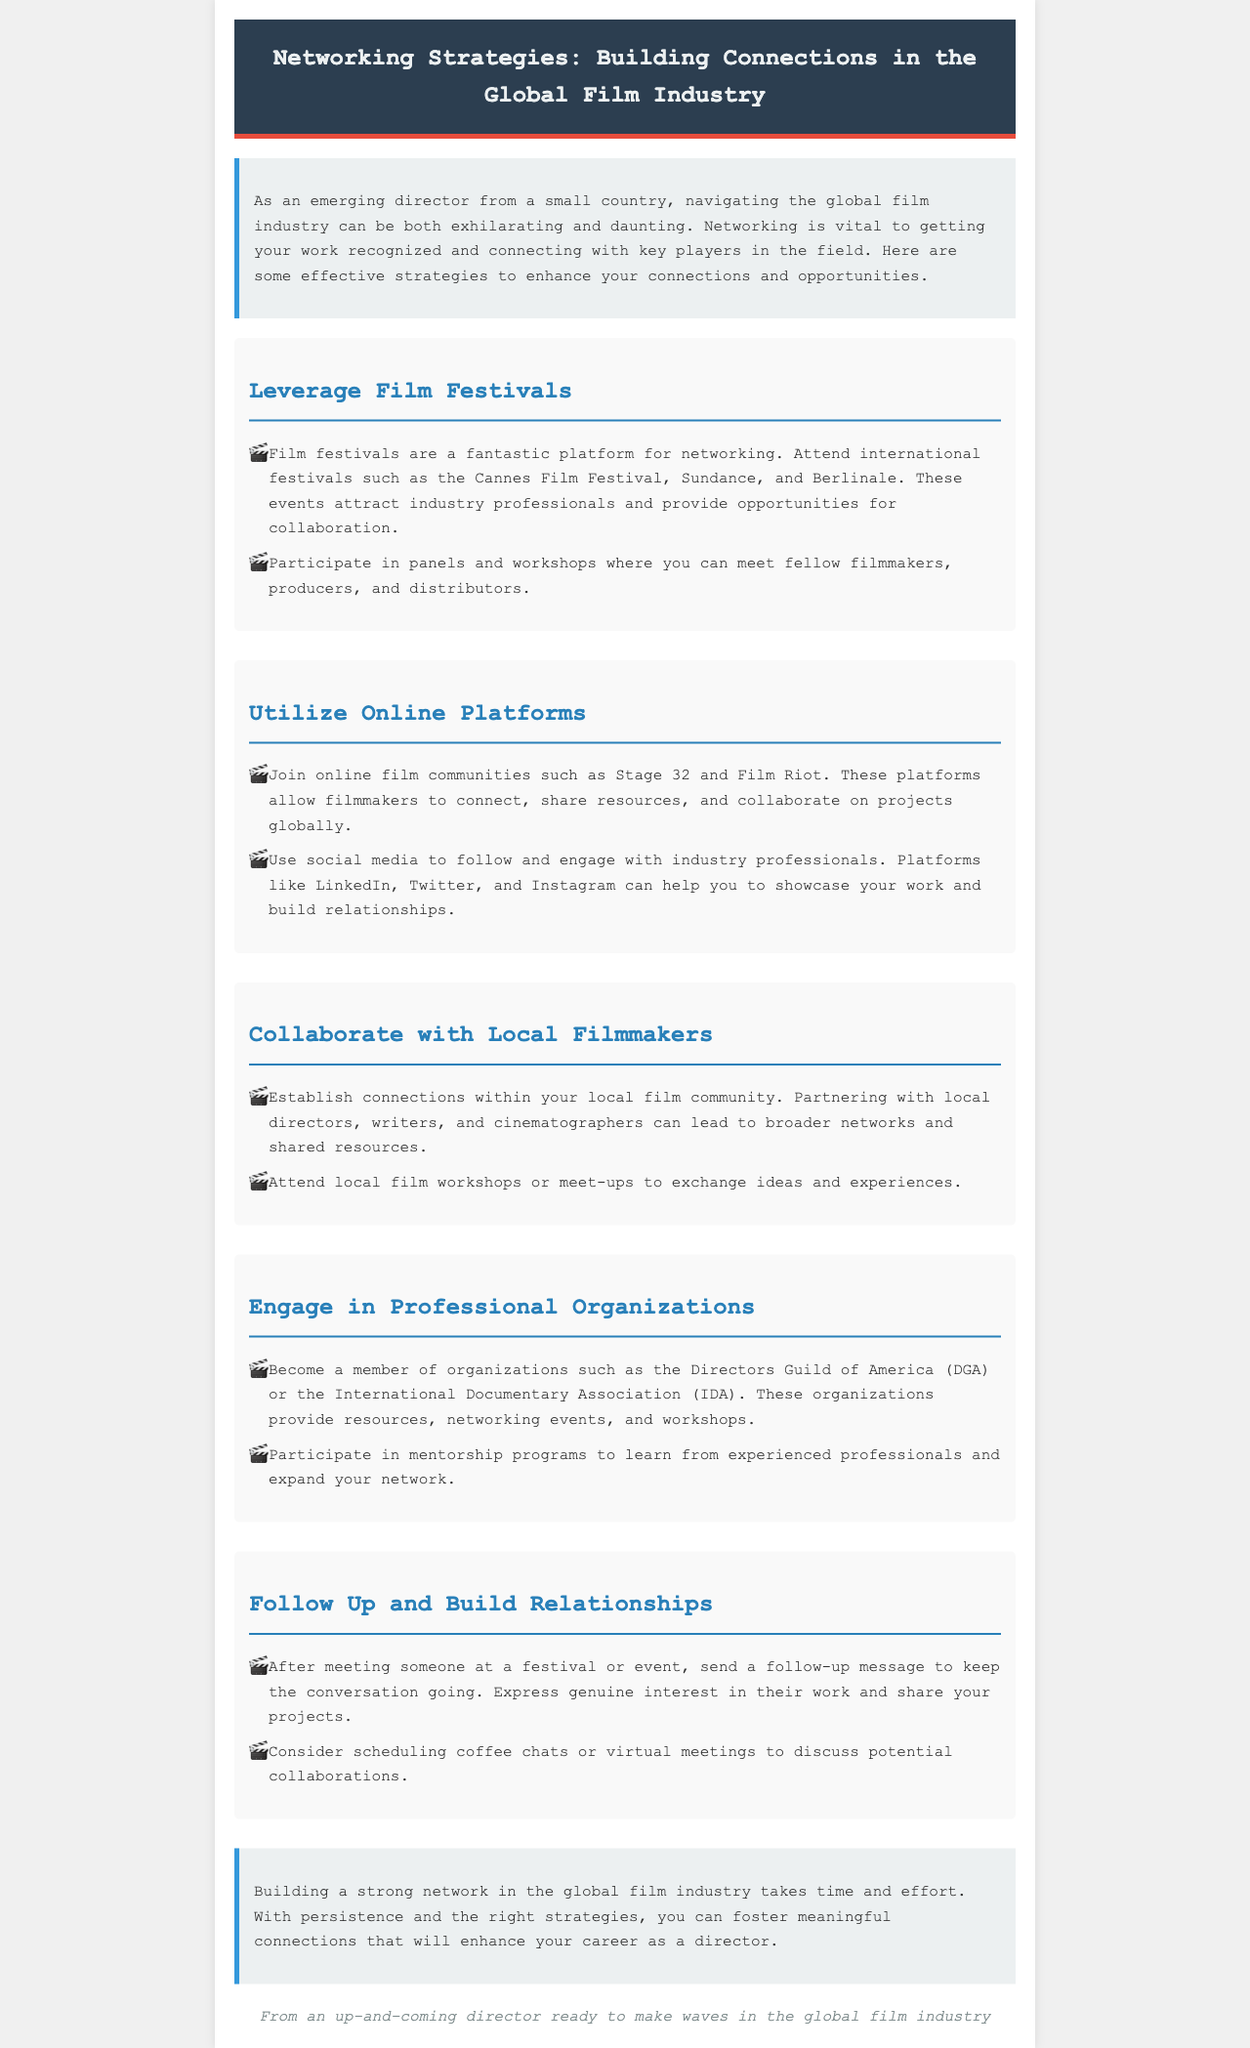What is the main purpose of the newsletter? The newsletter discusses strategies for networking within the global film industry for emerging directors.
Answer: Networking strategies How many sections are there in the document? There are five main sections detailing various networking strategies.
Answer: Five Which film festival is mentioned first? The first mentioned festival in the document is the Cannes Film Festival.
Answer: Cannes Film Festival What is one online platform suggested for networking? The document suggests joining online film communities such as Stage 32.
Answer: Stage 32 What is a recommended action after meeting someone at an event? The document recommends sending a follow-up message to keep the conversation going.
Answer: Follow-up message Which professional organization is suggested for filmmakers? The document mentions the Directors Guild of America (DGA) as a recommended organization.
Answer: Directors Guild of America What is the tone of the conclusion regarding networking? The conclusion encourages persistence in building meaningful connections in the film industry.
Answer: Encouragement How does the document suggest local filmmakers collaborate? It suggests partnering with local directors, writers, and cinematographers to expand networks.
Answer: Partnering with locals 